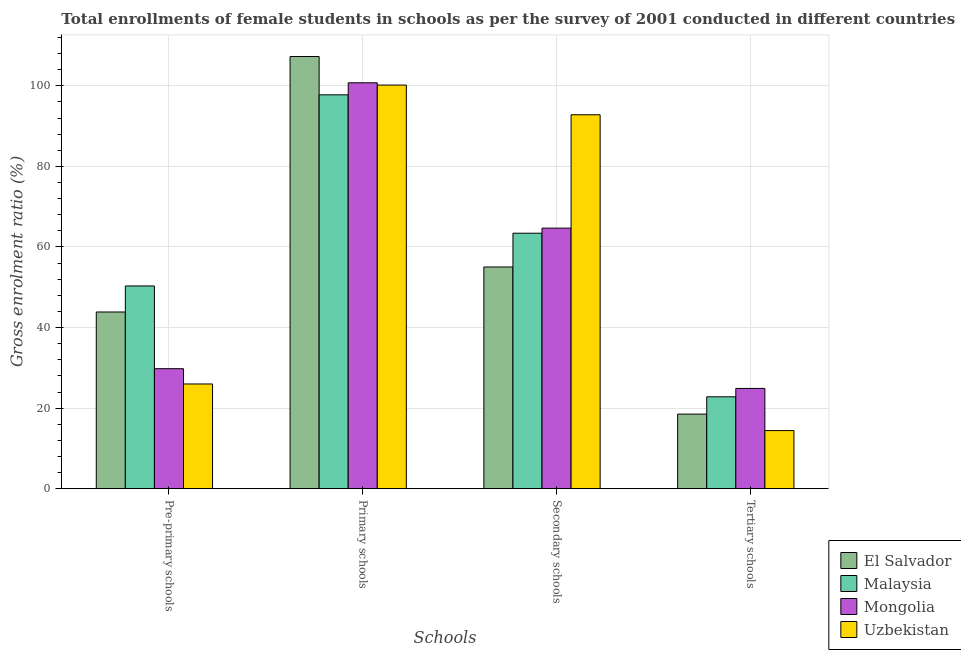How many groups of bars are there?
Your response must be concise. 4. Are the number of bars on each tick of the X-axis equal?
Your answer should be compact. Yes. How many bars are there on the 4th tick from the left?
Provide a short and direct response. 4. How many bars are there on the 3rd tick from the right?
Give a very brief answer. 4. What is the label of the 1st group of bars from the left?
Ensure brevity in your answer.  Pre-primary schools. What is the gross enrolment ratio(female) in tertiary schools in Uzbekistan?
Give a very brief answer. 14.42. Across all countries, what is the maximum gross enrolment ratio(female) in pre-primary schools?
Your answer should be very brief. 50.32. Across all countries, what is the minimum gross enrolment ratio(female) in pre-primary schools?
Your response must be concise. 25.99. In which country was the gross enrolment ratio(female) in primary schools maximum?
Offer a terse response. El Salvador. In which country was the gross enrolment ratio(female) in primary schools minimum?
Give a very brief answer. Malaysia. What is the total gross enrolment ratio(female) in pre-primary schools in the graph?
Provide a short and direct response. 149.97. What is the difference between the gross enrolment ratio(female) in tertiary schools in Mongolia and that in Uzbekistan?
Your answer should be very brief. 10.47. What is the difference between the gross enrolment ratio(female) in tertiary schools in Uzbekistan and the gross enrolment ratio(female) in secondary schools in El Salvador?
Your answer should be compact. -40.62. What is the average gross enrolment ratio(female) in primary schools per country?
Make the answer very short. 101.51. What is the difference between the gross enrolment ratio(female) in secondary schools and gross enrolment ratio(female) in tertiary schools in Mongolia?
Make the answer very short. 39.79. What is the ratio of the gross enrolment ratio(female) in tertiary schools in Mongolia to that in Uzbekistan?
Make the answer very short. 1.73. Is the gross enrolment ratio(female) in secondary schools in El Salvador less than that in Uzbekistan?
Make the answer very short. Yes. Is the difference between the gross enrolment ratio(female) in secondary schools in Uzbekistan and Mongolia greater than the difference between the gross enrolment ratio(female) in tertiary schools in Uzbekistan and Mongolia?
Provide a succinct answer. Yes. What is the difference between the highest and the second highest gross enrolment ratio(female) in pre-primary schools?
Make the answer very short. 6.46. What is the difference between the highest and the lowest gross enrolment ratio(female) in primary schools?
Give a very brief answer. 9.52. In how many countries, is the gross enrolment ratio(female) in primary schools greater than the average gross enrolment ratio(female) in primary schools taken over all countries?
Your response must be concise. 1. What does the 2nd bar from the left in Primary schools represents?
Your answer should be compact. Malaysia. What does the 2nd bar from the right in Tertiary schools represents?
Your answer should be very brief. Mongolia. Is it the case that in every country, the sum of the gross enrolment ratio(female) in pre-primary schools and gross enrolment ratio(female) in primary schools is greater than the gross enrolment ratio(female) in secondary schools?
Provide a short and direct response. Yes. How many bars are there?
Give a very brief answer. 16. Are all the bars in the graph horizontal?
Make the answer very short. No. What is the difference between two consecutive major ticks on the Y-axis?
Your answer should be very brief. 20. Are the values on the major ticks of Y-axis written in scientific E-notation?
Provide a short and direct response. No. Does the graph contain any zero values?
Provide a succinct answer. No. Does the graph contain grids?
Ensure brevity in your answer.  Yes. How are the legend labels stacked?
Keep it short and to the point. Vertical. What is the title of the graph?
Keep it short and to the point. Total enrollments of female students in schools as per the survey of 2001 conducted in different countries. Does "Suriname" appear as one of the legend labels in the graph?
Make the answer very short. No. What is the label or title of the X-axis?
Keep it short and to the point. Schools. What is the Gross enrolment ratio (%) of El Salvador in Pre-primary schools?
Ensure brevity in your answer.  43.86. What is the Gross enrolment ratio (%) in Malaysia in Pre-primary schools?
Make the answer very short. 50.32. What is the Gross enrolment ratio (%) of Mongolia in Pre-primary schools?
Your response must be concise. 29.79. What is the Gross enrolment ratio (%) of Uzbekistan in Pre-primary schools?
Offer a very short reply. 25.99. What is the Gross enrolment ratio (%) of El Salvador in Primary schools?
Your response must be concise. 107.29. What is the Gross enrolment ratio (%) of Malaysia in Primary schools?
Give a very brief answer. 97.78. What is the Gross enrolment ratio (%) in Mongolia in Primary schools?
Your answer should be very brief. 100.76. What is the Gross enrolment ratio (%) in Uzbekistan in Primary schools?
Your answer should be very brief. 100.2. What is the Gross enrolment ratio (%) in El Salvador in Secondary schools?
Give a very brief answer. 55.04. What is the Gross enrolment ratio (%) of Malaysia in Secondary schools?
Offer a terse response. 63.42. What is the Gross enrolment ratio (%) in Mongolia in Secondary schools?
Give a very brief answer. 64.68. What is the Gross enrolment ratio (%) in Uzbekistan in Secondary schools?
Offer a very short reply. 92.82. What is the Gross enrolment ratio (%) of El Salvador in Tertiary schools?
Keep it short and to the point. 18.51. What is the Gross enrolment ratio (%) in Malaysia in Tertiary schools?
Provide a short and direct response. 22.81. What is the Gross enrolment ratio (%) of Mongolia in Tertiary schools?
Keep it short and to the point. 24.89. What is the Gross enrolment ratio (%) in Uzbekistan in Tertiary schools?
Keep it short and to the point. 14.42. Across all Schools, what is the maximum Gross enrolment ratio (%) in El Salvador?
Your response must be concise. 107.29. Across all Schools, what is the maximum Gross enrolment ratio (%) in Malaysia?
Give a very brief answer. 97.78. Across all Schools, what is the maximum Gross enrolment ratio (%) in Mongolia?
Your answer should be very brief. 100.76. Across all Schools, what is the maximum Gross enrolment ratio (%) in Uzbekistan?
Your answer should be very brief. 100.2. Across all Schools, what is the minimum Gross enrolment ratio (%) in El Salvador?
Your answer should be compact. 18.51. Across all Schools, what is the minimum Gross enrolment ratio (%) in Malaysia?
Offer a terse response. 22.81. Across all Schools, what is the minimum Gross enrolment ratio (%) in Mongolia?
Your answer should be very brief. 24.89. Across all Schools, what is the minimum Gross enrolment ratio (%) in Uzbekistan?
Your answer should be compact. 14.42. What is the total Gross enrolment ratio (%) in El Salvador in the graph?
Give a very brief answer. 224.7. What is the total Gross enrolment ratio (%) in Malaysia in the graph?
Ensure brevity in your answer.  234.33. What is the total Gross enrolment ratio (%) of Mongolia in the graph?
Offer a terse response. 220.12. What is the total Gross enrolment ratio (%) in Uzbekistan in the graph?
Provide a succinct answer. 233.44. What is the difference between the Gross enrolment ratio (%) of El Salvador in Pre-primary schools and that in Primary schools?
Your answer should be very brief. -63.43. What is the difference between the Gross enrolment ratio (%) of Malaysia in Pre-primary schools and that in Primary schools?
Your answer should be very brief. -47.45. What is the difference between the Gross enrolment ratio (%) of Mongolia in Pre-primary schools and that in Primary schools?
Your answer should be very brief. -70.98. What is the difference between the Gross enrolment ratio (%) in Uzbekistan in Pre-primary schools and that in Primary schools?
Your response must be concise. -74.2. What is the difference between the Gross enrolment ratio (%) of El Salvador in Pre-primary schools and that in Secondary schools?
Your answer should be compact. -11.18. What is the difference between the Gross enrolment ratio (%) in Malaysia in Pre-primary schools and that in Secondary schools?
Keep it short and to the point. -13.1. What is the difference between the Gross enrolment ratio (%) of Mongolia in Pre-primary schools and that in Secondary schools?
Your response must be concise. -34.9. What is the difference between the Gross enrolment ratio (%) in Uzbekistan in Pre-primary schools and that in Secondary schools?
Ensure brevity in your answer.  -66.83. What is the difference between the Gross enrolment ratio (%) of El Salvador in Pre-primary schools and that in Tertiary schools?
Provide a succinct answer. 25.35. What is the difference between the Gross enrolment ratio (%) in Malaysia in Pre-primary schools and that in Tertiary schools?
Give a very brief answer. 27.52. What is the difference between the Gross enrolment ratio (%) in Mongolia in Pre-primary schools and that in Tertiary schools?
Make the answer very short. 4.9. What is the difference between the Gross enrolment ratio (%) of Uzbekistan in Pre-primary schools and that in Tertiary schools?
Your answer should be very brief. 11.57. What is the difference between the Gross enrolment ratio (%) in El Salvador in Primary schools and that in Secondary schools?
Provide a short and direct response. 52.26. What is the difference between the Gross enrolment ratio (%) in Malaysia in Primary schools and that in Secondary schools?
Provide a succinct answer. 34.36. What is the difference between the Gross enrolment ratio (%) of Mongolia in Primary schools and that in Secondary schools?
Offer a very short reply. 36.08. What is the difference between the Gross enrolment ratio (%) in Uzbekistan in Primary schools and that in Secondary schools?
Give a very brief answer. 7.38. What is the difference between the Gross enrolment ratio (%) of El Salvador in Primary schools and that in Tertiary schools?
Provide a short and direct response. 88.78. What is the difference between the Gross enrolment ratio (%) in Malaysia in Primary schools and that in Tertiary schools?
Provide a short and direct response. 74.97. What is the difference between the Gross enrolment ratio (%) in Mongolia in Primary schools and that in Tertiary schools?
Make the answer very short. 75.88. What is the difference between the Gross enrolment ratio (%) in Uzbekistan in Primary schools and that in Tertiary schools?
Your answer should be very brief. 85.78. What is the difference between the Gross enrolment ratio (%) in El Salvador in Secondary schools and that in Tertiary schools?
Your answer should be very brief. 36.53. What is the difference between the Gross enrolment ratio (%) in Malaysia in Secondary schools and that in Tertiary schools?
Your answer should be compact. 40.62. What is the difference between the Gross enrolment ratio (%) in Mongolia in Secondary schools and that in Tertiary schools?
Offer a terse response. 39.79. What is the difference between the Gross enrolment ratio (%) in Uzbekistan in Secondary schools and that in Tertiary schools?
Make the answer very short. 78.4. What is the difference between the Gross enrolment ratio (%) in El Salvador in Pre-primary schools and the Gross enrolment ratio (%) in Malaysia in Primary schools?
Provide a short and direct response. -53.92. What is the difference between the Gross enrolment ratio (%) in El Salvador in Pre-primary schools and the Gross enrolment ratio (%) in Mongolia in Primary schools?
Make the answer very short. -56.9. What is the difference between the Gross enrolment ratio (%) of El Salvador in Pre-primary schools and the Gross enrolment ratio (%) of Uzbekistan in Primary schools?
Provide a short and direct response. -56.34. What is the difference between the Gross enrolment ratio (%) of Malaysia in Pre-primary schools and the Gross enrolment ratio (%) of Mongolia in Primary schools?
Offer a terse response. -50.44. What is the difference between the Gross enrolment ratio (%) of Malaysia in Pre-primary schools and the Gross enrolment ratio (%) of Uzbekistan in Primary schools?
Give a very brief answer. -49.87. What is the difference between the Gross enrolment ratio (%) of Mongolia in Pre-primary schools and the Gross enrolment ratio (%) of Uzbekistan in Primary schools?
Your answer should be very brief. -70.41. What is the difference between the Gross enrolment ratio (%) in El Salvador in Pre-primary schools and the Gross enrolment ratio (%) in Malaysia in Secondary schools?
Make the answer very short. -19.56. What is the difference between the Gross enrolment ratio (%) of El Salvador in Pre-primary schools and the Gross enrolment ratio (%) of Mongolia in Secondary schools?
Your answer should be compact. -20.82. What is the difference between the Gross enrolment ratio (%) in El Salvador in Pre-primary schools and the Gross enrolment ratio (%) in Uzbekistan in Secondary schools?
Your answer should be compact. -48.96. What is the difference between the Gross enrolment ratio (%) in Malaysia in Pre-primary schools and the Gross enrolment ratio (%) in Mongolia in Secondary schools?
Your answer should be compact. -14.36. What is the difference between the Gross enrolment ratio (%) in Malaysia in Pre-primary schools and the Gross enrolment ratio (%) in Uzbekistan in Secondary schools?
Provide a succinct answer. -42.5. What is the difference between the Gross enrolment ratio (%) of Mongolia in Pre-primary schools and the Gross enrolment ratio (%) of Uzbekistan in Secondary schools?
Give a very brief answer. -63.04. What is the difference between the Gross enrolment ratio (%) of El Salvador in Pre-primary schools and the Gross enrolment ratio (%) of Malaysia in Tertiary schools?
Offer a very short reply. 21.06. What is the difference between the Gross enrolment ratio (%) of El Salvador in Pre-primary schools and the Gross enrolment ratio (%) of Mongolia in Tertiary schools?
Your response must be concise. 18.97. What is the difference between the Gross enrolment ratio (%) of El Salvador in Pre-primary schools and the Gross enrolment ratio (%) of Uzbekistan in Tertiary schools?
Keep it short and to the point. 29.44. What is the difference between the Gross enrolment ratio (%) of Malaysia in Pre-primary schools and the Gross enrolment ratio (%) of Mongolia in Tertiary schools?
Provide a succinct answer. 25.44. What is the difference between the Gross enrolment ratio (%) in Malaysia in Pre-primary schools and the Gross enrolment ratio (%) in Uzbekistan in Tertiary schools?
Give a very brief answer. 35.9. What is the difference between the Gross enrolment ratio (%) in Mongolia in Pre-primary schools and the Gross enrolment ratio (%) in Uzbekistan in Tertiary schools?
Make the answer very short. 15.36. What is the difference between the Gross enrolment ratio (%) of El Salvador in Primary schools and the Gross enrolment ratio (%) of Malaysia in Secondary schools?
Offer a terse response. 43.87. What is the difference between the Gross enrolment ratio (%) of El Salvador in Primary schools and the Gross enrolment ratio (%) of Mongolia in Secondary schools?
Make the answer very short. 42.61. What is the difference between the Gross enrolment ratio (%) of El Salvador in Primary schools and the Gross enrolment ratio (%) of Uzbekistan in Secondary schools?
Keep it short and to the point. 14.47. What is the difference between the Gross enrolment ratio (%) of Malaysia in Primary schools and the Gross enrolment ratio (%) of Mongolia in Secondary schools?
Provide a succinct answer. 33.1. What is the difference between the Gross enrolment ratio (%) in Malaysia in Primary schools and the Gross enrolment ratio (%) in Uzbekistan in Secondary schools?
Provide a short and direct response. 4.96. What is the difference between the Gross enrolment ratio (%) in Mongolia in Primary schools and the Gross enrolment ratio (%) in Uzbekistan in Secondary schools?
Keep it short and to the point. 7.94. What is the difference between the Gross enrolment ratio (%) in El Salvador in Primary schools and the Gross enrolment ratio (%) in Malaysia in Tertiary schools?
Your response must be concise. 84.49. What is the difference between the Gross enrolment ratio (%) in El Salvador in Primary schools and the Gross enrolment ratio (%) in Mongolia in Tertiary schools?
Make the answer very short. 82.41. What is the difference between the Gross enrolment ratio (%) of El Salvador in Primary schools and the Gross enrolment ratio (%) of Uzbekistan in Tertiary schools?
Your response must be concise. 92.87. What is the difference between the Gross enrolment ratio (%) in Malaysia in Primary schools and the Gross enrolment ratio (%) in Mongolia in Tertiary schools?
Give a very brief answer. 72.89. What is the difference between the Gross enrolment ratio (%) of Malaysia in Primary schools and the Gross enrolment ratio (%) of Uzbekistan in Tertiary schools?
Give a very brief answer. 83.36. What is the difference between the Gross enrolment ratio (%) in Mongolia in Primary schools and the Gross enrolment ratio (%) in Uzbekistan in Tertiary schools?
Your answer should be very brief. 86.34. What is the difference between the Gross enrolment ratio (%) of El Salvador in Secondary schools and the Gross enrolment ratio (%) of Malaysia in Tertiary schools?
Offer a very short reply. 32.23. What is the difference between the Gross enrolment ratio (%) of El Salvador in Secondary schools and the Gross enrolment ratio (%) of Mongolia in Tertiary schools?
Your response must be concise. 30.15. What is the difference between the Gross enrolment ratio (%) of El Salvador in Secondary schools and the Gross enrolment ratio (%) of Uzbekistan in Tertiary schools?
Keep it short and to the point. 40.62. What is the difference between the Gross enrolment ratio (%) of Malaysia in Secondary schools and the Gross enrolment ratio (%) of Mongolia in Tertiary schools?
Your answer should be compact. 38.53. What is the difference between the Gross enrolment ratio (%) of Malaysia in Secondary schools and the Gross enrolment ratio (%) of Uzbekistan in Tertiary schools?
Keep it short and to the point. 49. What is the difference between the Gross enrolment ratio (%) of Mongolia in Secondary schools and the Gross enrolment ratio (%) of Uzbekistan in Tertiary schools?
Keep it short and to the point. 50.26. What is the average Gross enrolment ratio (%) of El Salvador per Schools?
Your answer should be very brief. 56.18. What is the average Gross enrolment ratio (%) in Malaysia per Schools?
Your answer should be very brief. 58.58. What is the average Gross enrolment ratio (%) of Mongolia per Schools?
Give a very brief answer. 55.03. What is the average Gross enrolment ratio (%) in Uzbekistan per Schools?
Keep it short and to the point. 58.36. What is the difference between the Gross enrolment ratio (%) of El Salvador and Gross enrolment ratio (%) of Malaysia in Pre-primary schools?
Offer a very short reply. -6.46. What is the difference between the Gross enrolment ratio (%) in El Salvador and Gross enrolment ratio (%) in Mongolia in Pre-primary schools?
Make the answer very short. 14.08. What is the difference between the Gross enrolment ratio (%) of El Salvador and Gross enrolment ratio (%) of Uzbekistan in Pre-primary schools?
Give a very brief answer. 17.87. What is the difference between the Gross enrolment ratio (%) of Malaysia and Gross enrolment ratio (%) of Mongolia in Pre-primary schools?
Your response must be concise. 20.54. What is the difference between the Gross enrolment ratio (%) of Malaysia and Gross enrolment ratio (%) of Uzbekistan in Pre-primary schools?
Your answer should be very brief. 24.33. What is the difference between the Gross enrolment ratio (%) in Mongolia and Gross enrolment ratio (%) in Uzbekistan in Pre-primary schools?
Make the answer very short. 3.79. What is the difference between the Gross enrolment ratio (%) in El Salvador and Gross enrolment ratio (%) in Malaysia in Primary schools?
Your answer should be compact. 9.52. What is the difference between the Gross enrolment ratio (%) of El Salvador and Gross enrolment ratio (%) of Mongolia in Primary schools?
Your answer should be very brief. 6.53. What is the difference between the Gross enrolment ratio (%) in El Salvador and Gross enrolment ratio (%) in Uzbekistan in Primary schools?
Your response must be concise. 7.1. What is the difference between the Gross enrolment ratio (%) in Malaysia and Gross enrolment ratio (%) in Mongolia in Primary schools?
Your response must be concise. -2.99. What is the difference between the Gross enrolment ratio (%) in Malaysia and Gross enrolment ratio (%) in Uzbekistan in Primary schools?
Provide a succinct answer. -2.42. What is the difference between the Gross enrolment ratio (%) of Mongolia and Gross enrolment ratio (%) of Uzbekistan in Primary schools?
Your answer should be very brief. 0.57. What is the difference between the Gross enrolment ratio (%) in El Salvador and Gross enrolment ratio (%) in Malaysia in Secondary schools?
Keep it short and to the point. -8.38. What is the difference between the Gross enrolment ratio (%) in El Salvador and Gross enrolment ratio (%) in Mongolia in Secondary schools?
Offer a terse response. -9.64. What is the difference between the Gross enrolment ratio (%) of El Salvador and Gross enrolment ratio (%) of Uzbekistan in Secondary schools?
Provide a short and direct response. -37.79. What is the difference between the Gross enrolment ratio (%) of Malaysia and Gross enrolment ratio (%) of Mongolia in Secondary schools?
Provide a short and direct response. -1.26. What is the difference between the Gross enrolment ratio (%) in Malaysia and Gross enrolment ratio (%) in Uzbekistan in Secondary schools?
Make the answer very short. -29.4. What is the difference between the Gross enrolment ratio (%) in Mongolia and Gross enrolment ratio (%) in Uzbekistan in Secondary schools?
Your response must be concise. -28.14. What is the difference between the Gross enrolment ratio (%) in El Salvador and Gross enrolment ratio (%) in Malaysia in Tertiary schools?
Your answer should be compact. -4.3. What is the difference between the Gross enrolment ratio (%) of El Salvador and Gross enrolment ratio (%) of Mongolia in Tertiary schools?
Give a very brief answer. -6.38. What is the difference between the Gross enrolment ratio (%) of El Salvador and Gross enrolment ratio (%) of Uzbekistan in Tertiary schools?
Make the answer very short. 4.09. What is the difference between the Gross enrolment ratio (%) of Malaysia and Gross enrolment ratio (%) of Mongolia in Tertiary schools?
Provide a short and direct response. -2.08. What is the difference between the Gross enrolment ratio (%) of Malaysia and Gross enrolment ratio (%) of Uzbekistan in Tertiary schools?
Ensure brevity in your answer.  8.38. What is the difference between the Gross enrolment ratio (%) of Mongolia and Gross enrolment ratio (%) of Uzbekistan in Tertiary schools?
Offer a terse response. 10.47. What is the ratio of the Gross enrolment ratio (%) of El Salvador in Pre-primary schools to that in Primary schools?
Your answer should be compact. 0.41. What is the ratio of the Gross enrolment ratio (%) in Malaysia in Pre-primary schools to that in Primary schools?
Keep it short and to the point. 0.51. What is the ratio of the Gross enrolment ratio (%) of Mongolia in Pre-primary schools to that in Primary schools?
Ensure brevity in your answer.  0.3. What is the ratio of the Gross enrolment ratio (%) of Uzbekistan in Pre-primary schools to that in Primary schools?
Provide a succinct answer. 0.26. What is the ratio of the Gross enrolment ratio (%) of El Salvador in Pre-primary schools to that in Secondary schools?
Provide a short and direct response. 0.8. What is the ratio of the Gross enrolment ratio (%) in Malaysia in Pre-primary schools to that in Secondary schools?
Keep it short and to the point. 0.79. What is the ratio of the Gross enrolment ratio (%) of Mongolia in Pre-primary schools to that in Secondary schools?
Offer a very short reply. 0.46. What is the ratio of the Gross enrolment ratio (%) of Uzbekistan in Pre-primary schools to that in Secondary schools?
Provide a succinct answer. 0.28. What is the ratio of the Gross enrolment ratio (%) of El Salvador in Pre-primary schools to that in Tertiary schools?
Your answer should be compact. 2.37. What is the ratio of the Gross enrolment ratio (%) of Malaysia in Pre-primary schools to that in Tertiary schools?
Provide a succinct answer. 2.21. What is the ratio of the Gross enrolment ratio (%) of Mongolia in Pre-primary schools to that in Tertiary schools?
Offer a terse response. 1.2. What is the ratio of the Gross enrolment ratio (%) of Uzbekistan in Pre-primary schools to that in Tertiary schools?
Offer a very short reply. 1.8. What is the ratio of the Gross enrolment ratio (%) of El Salvador in Primary schools to that in Secondary schools?
Make the answer very short. 1.95. What is the ratio of the Gross enrolment ratio (%) of Malaysia in Primary schools to that in Secondary schools?
Your answer should be compact. 1.54. What is the ratio of the Gross enrolment ratio (%) of Mongolia in Primary schools to that in Secondary schools?
Offer a terse response. 1.56. What is the ratio of the Gross enrolment ratio (%) in Uzbekistan in Primary schools to that in Secondary schools?
Offer a very short reply. 1.08. What is the ratio of the Gross enrolment ratio (%) of El Salvador in Primary schools to that in Tertiary schools?
Make the answer very short. 5.8. What is the ratio of the Gross enrolment ratio (%) in Malaysia in Primary schools to that in Tertiary schools?
Provide a short and direct response. 4.29. What is the ratio of the Gross enrolment ratio (%) in Mongolia in Primary schools to that in Tertiary schools?
Keep it short and to the point. 4.05. What is the ratio of the Gross enrolment ratio (%) in Uzbekistan in Primary schools to that in Tertiary schools?
Provide a short and direct response. 6.95. What is the ratio of the Gross enrolment ratio (%) in El Salvador in Secondary schools to that in Tertiary schools?
Give a very brief answer. 2.97. What is the ratio of the Gross enrolment ratio (%) of Malaysia in Secondary schools to that in Tertiary schools?
Make the answer very short. 2.78. What is the ratio of the Gross enrolment ratio (%) in Mongolia in Secondary schools to that in Tertiary schools?
Your response must be concise. 2.6. What is the ratio of the Gross enrolment ratio (%) of Uzbekistan in Secondary schools to that in Tertiary schools?
Provide a succinct answer. 6.44. What is the difference between the highest and the second highest Gross enrolment ratio (%) in El Salvador?
Provide a short and direct response. 52.26. What is the difference between the highest and the second highest Gross enrolment ratio (%) of Malaysia?
Your answer should be compact. 34.36. What is the difference between the highest and the second highest Gross enrolment ratio (%) of Mongolia?
Keep it short and to the point. 36.08. What is the difference between the highest and the second highest Gross enrolment ratio (%) in Uzbekistan?
Offer a very short reply. 7.38. What is the difference between the highest and the lowest Gross enrolment ratio (%) of El Salvador?
Ensure brevity in your answer.  88.78. What is the difference between the highest and the lowest Gross enrolment ratio (%) of Malaysia?
Ensure brevity in your answer.  74.97. What is the difference between the highest and the lowest Gross enrolment ratio (%) of Mongolia?
Give a very brief answer. 75.88. What is the difference between the highest and the lowest Gross enrolment ratio (%) of Uzbekistan?
Keep it short and to the point. 85.78. 